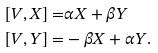Convert formula to latex. <formula><loc_0><loc_0><loc_500><loc_500>[ V , X ] = & \alpha X + \beta Y \\ [ V , Y ] = & - \beta X + \alpha Y .</formula> 